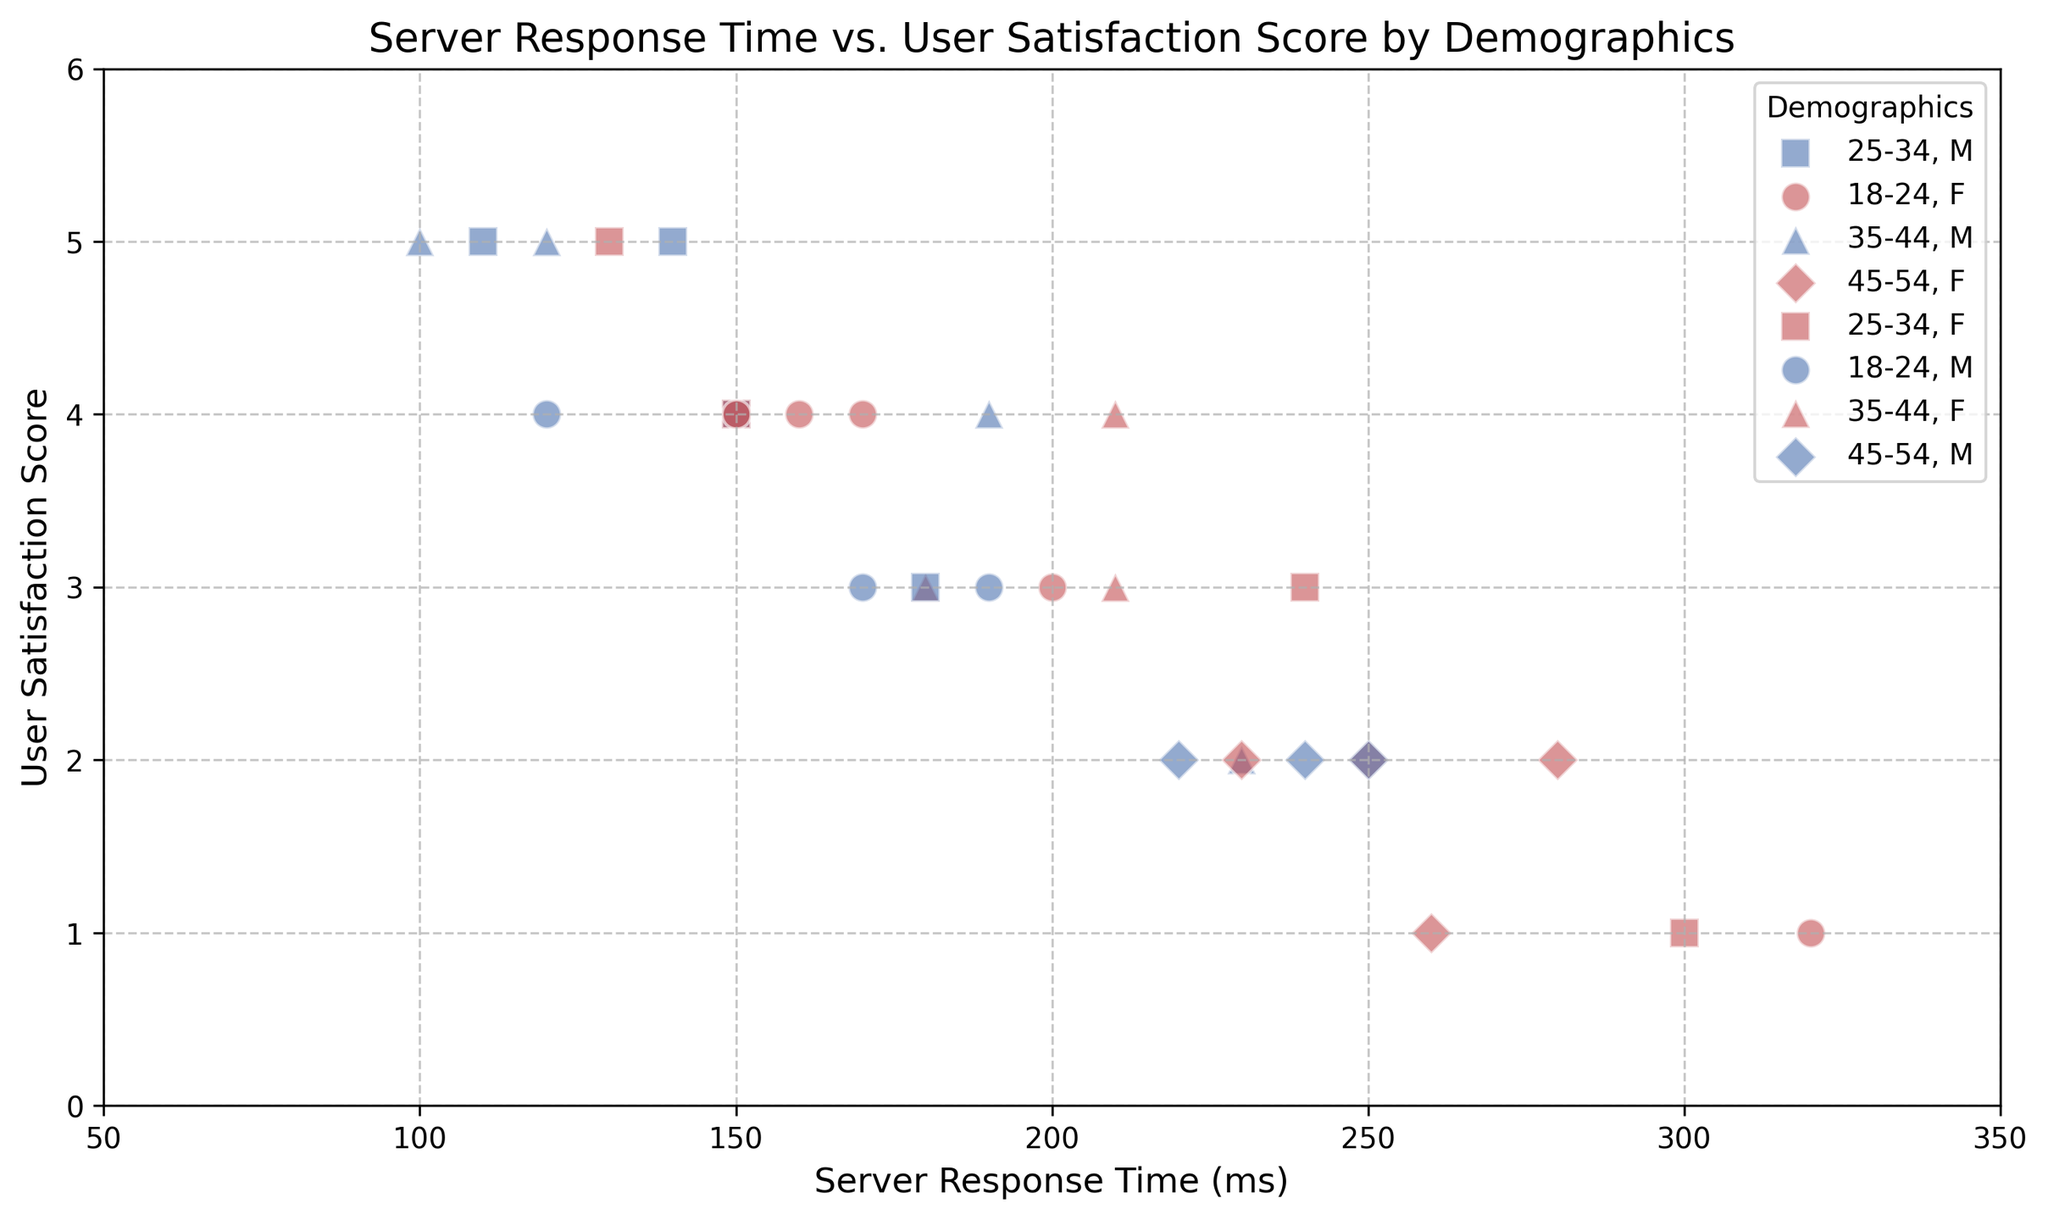Which age group has the highest user satisfaction score in the figure? To find the age group with the highest score, look for the highest point on the y-axis. The highest user satisfaction score is 5, which is marked by 'squares' (for age group 25-34) and some 'triangles' (for age group 35-44).
Answer: 25-34 and 35-44 Which gender generally experiences higher user satisfaction scores in the figure? To determine which gender has higher satisfaction scores, look at the colors. Red points (female) often reach the highest score of 5, whereas blue points (male) are distributed across various lower scores too.
Answer: Female Which location appears to have the shortest server response time based on the scatter plot? By observing which points are closest to the left on the x-axis, we see that some points for locations like Canada and UK consistently fall around lower values such as 100-120 ms.
Answer: Canada and UK Are there any demographics where user satisfaction scores seem to diminish significantly with increasing server response time? Check for points that exhibit a declining trend as we move right along the x-axis. For example, the 45-54 age group shows lower satisfaction scores (1-2) with longer server response times (e.g., greater than 220 ms).
Answer: 45-54 What is the general trend in user satisfaction as the server response time increases? Observe the general orientation of the points. As server response time increases (moves right), user satisfaction scores generally decrease (move down).
Answer: Decreasing Which demographic has the most diverse range of server response times? Look for markers spread widely along the x-axis for a specific demographic. The 25-34 age group, for example, has points ranging from around 100 ms to 300 ms.
Answer: 25-34 Is there an apparent relationship between the 18-24 age group's response time and their satisfaction scores? For the age group 18-24 ('o' markers), observe the distribution of points along the x and y-axes. The 18-24 age group points are somewhat scattered but also show some high scores (4) at lower response times and lower scores as response time increases.
Answer: Generally decreasing Which user group appears to be the most satisfied irrespective of server response times? Look for a group with mostly higher satisfaction scores regardless of their position on the x-axis. Age groups 25-34 ('squares') and 35-44 ('triangles') have several high satisfaction points even with varied server response times.
Answer: 25-34 and 35-44 Among the scatter plot points, which marker (shape) is the most frequently associated with the lowest user satisfaction scores? Identify the shape markers that frequently appear at the bottom of the y-axis (1-2 scores). The diamonds ('D') representing 45-54 age group show the lowest satisfaction scores more often.
Answer: Diamonds (45-54) For the 25-34 age group, are males or females more satisfied with server response times under 200 ms? Compare the red squares (female, 25-34 age) vs. blue squares (male, 25-34 age) under the 200 ms mark on the x-axis. The red squares tend to have higher scores (4-5) than the blue squares.
Answer: Females 